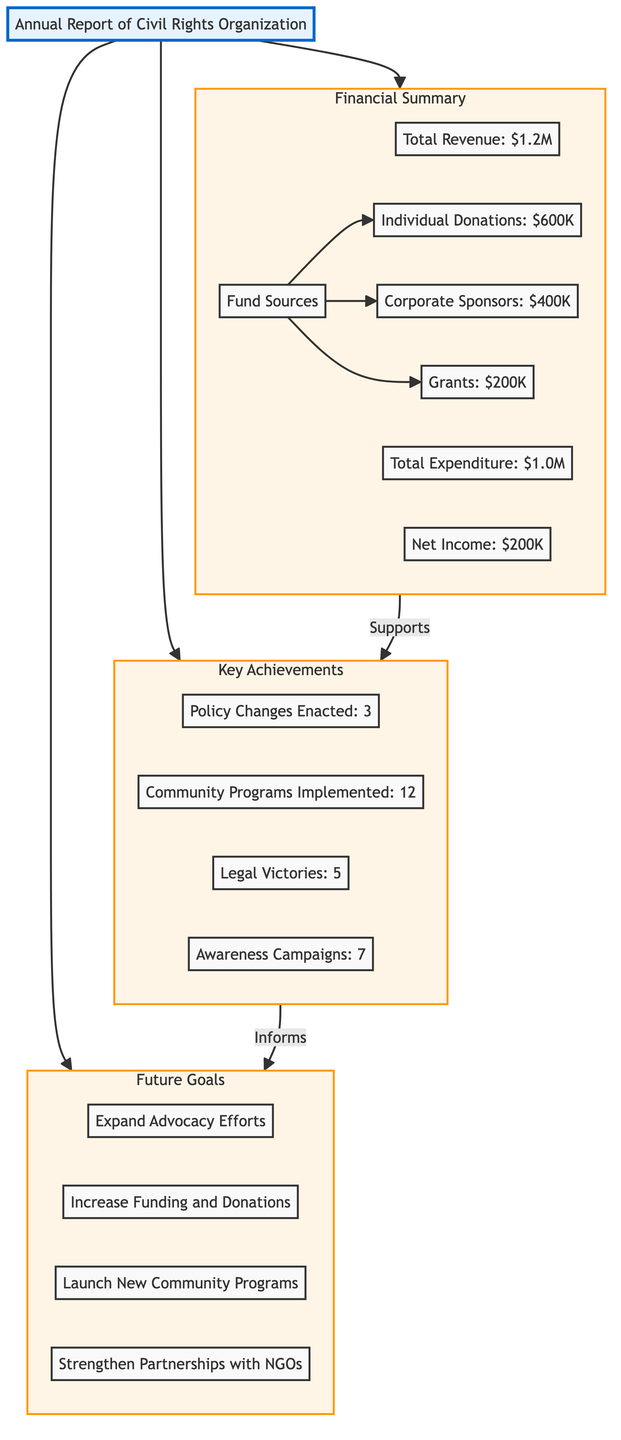What is the total revenue reported in the financial summary? The financial summary node shows the total revenue directly as part of the description. It is explicitly listed as $1.2M.
Answer: $1.2M How many achievements are listed in the key achievements section? The key achievements section includes four specific nodes: Policy Changes Enacted, Community Programs Implemented, Legal Victories, and Awareness Campaigns. Thus, there are a total of four achievements.
Answer: 4 What is the total expenditure according to the financial summary? From the financial summary node, the total expenditure is clearly stated as $1.0M.
Answer: $1.0M What are the primary sources of funds according to the financial summary? The fund sources node outlines three types of funding: Individual Donations, Corporate Sponsors, and Grants. I can list them as these three specific categories.
Answer: Individual Donations, Corporate Sponsors, Grants How many community programs were implemented as key achievements? The specific node under key achievements for community programs states "Community Programs Implemented: 12", which provides the exact count of how many programs were carried out.
Answer: 12 Which section follows the financial summary in the diagram? The flow shows that after Financial Summary, the next node is Key Achievements, indicating the relationship and order of these sections.
Answer: Key Achievements Which goal aims to increase resources for the organization? The Future Goals subgraph specifies "Increase Funding and Donations," which is focused on boosting the organization's financial resources.
Answer: Increase Funding How many legal victories are marked as achievements? Within the key achievements, the node specifically states "Legal Victories: 5," providing a direct answer to the question of how many legal victories were achieved.
Answer: 5 Which new initiative is included as a future goal? Among the future goals, "Launch New Community Programs" is explicitly presented as a new initiative that the organization aims to pursue moving forward.
Answer: Launch New Community Programs 